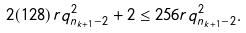<formula> <loc_0><loc_0><loc_500><loc_500>2 ( 1 2 8 ) r q _ { n _ { k + 1 } - 2 } ^ { 2 } + 2 \leq 2 5 6 r q _ { n _ { k + 1 } - 2 } ^ { 2 } .</formula> 